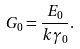<formula> <loc_0><loc_0><loc_500><loc_500>G _ { 0 } = \frac { E _ { 0 } } { k \gamma _ { 0 } } .</formula> 